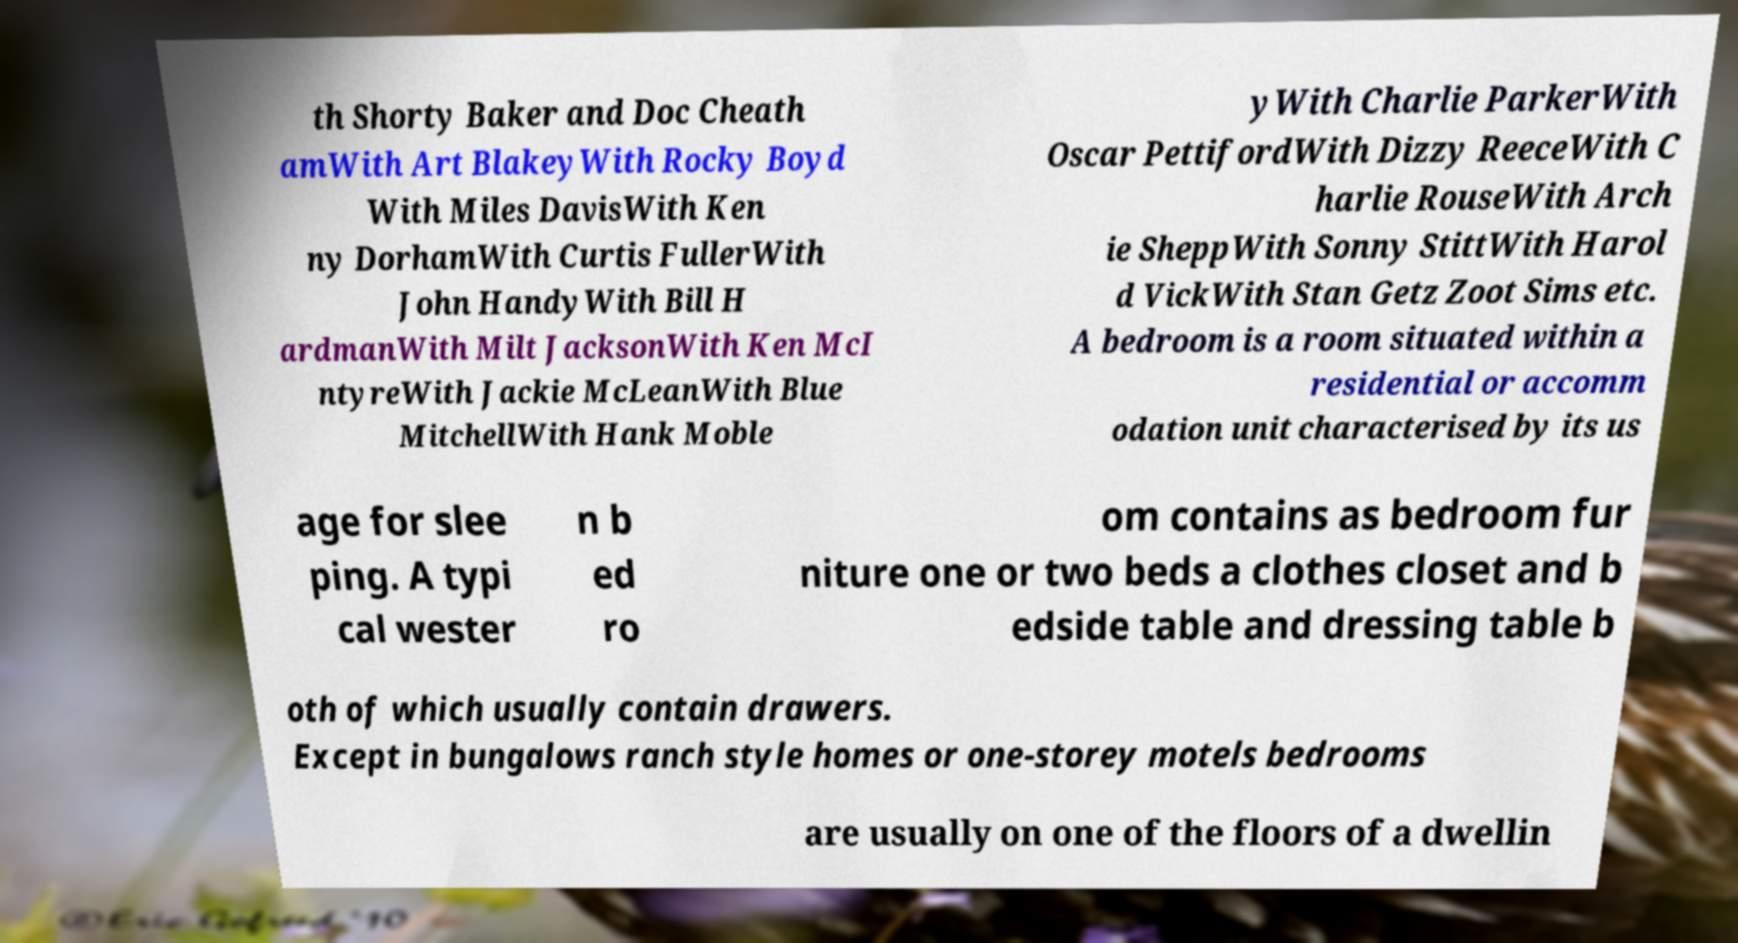Can you accurately transcribe the text from the provided image for me? th Shorty Baker and Doc Cheath amWith Art BlakeyWith Rocky Boyd With Miles DavisWith Ken ny DorhamWith Curtis FullerWith John HandyWith Bill H ardmanWith Milt JacksonWith Ken McI ntyreWith Jackie McLeanWith Blue MitchellWith Hank Moble yWith Charlie ParkerWith Oscar PettifordWith Dizzy ReeceWith C harlie RouseWith Arch ie SheppWith Sonny StittWith Harol d VickWith Stan Getz Zoot Sims etc. A bedroom is a room situated within a residential or accomm odation unit characterised by its us age for slee ping. A typi cal wester n b ed ro om contains as bedroom fur niture one or two beds a clothes closet and b edside table and dressing table b oth of which usually contain drawers. Except in bungalows ranch style homes or one-storey motels bedrooms are usually on one of the floors of a dwellin 